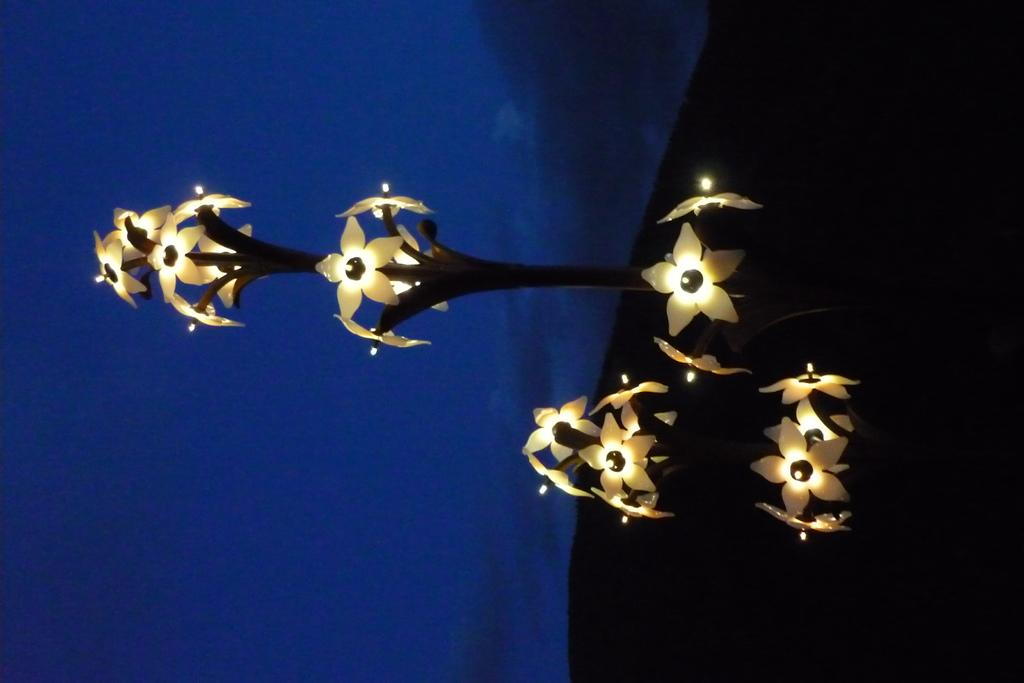What type of plant is located on the right side of the image? There is an artificial plant with artificial flowers on the right side of the image. What can be seen in the background of the image? There are clouds in the background of the image. What color is the sky in the image? The sky is blue in the image. What time is displayed on the clock in the image? There is no clock present in the image. What part of the face can be seen on the chin in the image? There is no chin or face present in the image. 